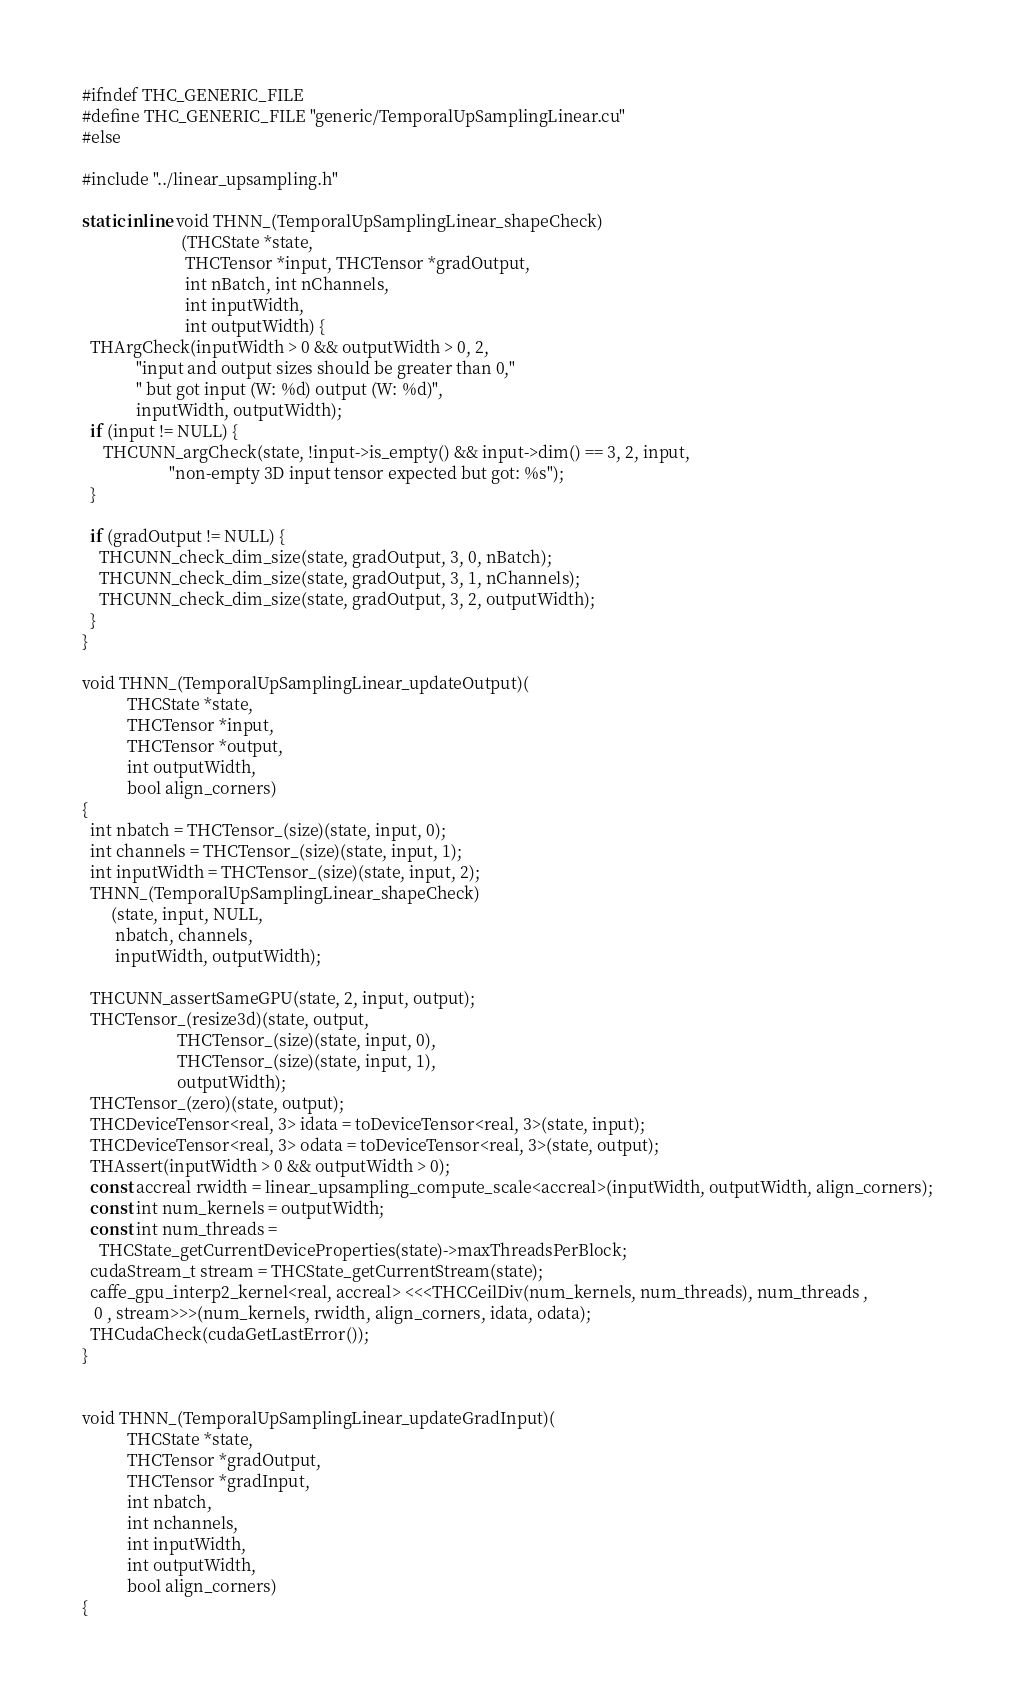Convert code to text. <code><loc_0><loc_0><loc_500><loc_500><_Cuda_>#ifndef THC_GENERIC_FILE
#define THC_GENERIC_FILE "generic/TemporalUpSamplingLinear.cu"
#else

#include "../linear_upsampling.h"

static inline void THNN_(TemporalUpSamplingLinear_shapeCheck)
                        (THCState *state,
                         THCTensor *input, THCTensor *gradOutput,
                         int nBatch, int nChannels,
                         int inputWidth,
                         int outputWidth) {
  THArgCheck(inputWidth > 0 && outputWidth > 0, 2,
             "input and output sizes should be greater than 0,"
             " but got input (W: %d) output (W: %d)",
             inputWidth, outputWidth);
  if (input != NULL) {
     THCUNN_argCheck(state, !input->is_empty() && input->dim() == 3, 2, input,
                     "non-empty 3D input tensor expected but got: %s");
  }

  if (gradOutput != NULL) {
    THCUNN_check_dim_size(state, gradOutput, 3, 0, nBatch);
    THCUNN_check_dim_size(state, gradOutput, 3, 1, nChannels);
    THCUNN_check_dim_size(state, gradOutput, 3, 2, outputWidth);
  }
}

void THNN_(TemporalUpSamplingLinear_updateOutput)(
           THCState *state,
           THCTensor *input,
           THCTensor *output,
           int outputWidth,
           bool align_corners)
{
  int nbatch = THCTensor_(size)(state, input, 0);
  int channels = THCTensor_(size)(state, input, 1);
  int inputWidth = THCTensor_(size)(state, input, 2);
  THNN_(TemporalUpSamplingLinear_shapeCheck)
       (state, input, NULL,
        nbatch, channels,
        inputWidth, outputWidth);

  THCUNN_assertSameGPU(state, 2, input, output);
  THCTensor_(resize3d)(state, output,
                       THCTensor_(size)(state, input, 0),
                       THCTensor_(size)(state, input, 1),
                       outputWidth);
  THCTensor_(zero)(state, output);
  THCDeviceTensor<real, 3> idata = toDeviceTensor<real, 3>(state, input);
  THCDeviceTensor<real, 3> odata = toDeviceTensor<real, 3>(state, output);
  THAssert(inputWidth > 0 && outputWidth > 0);
  const accreal rwidth = linear_upsampling_compute_scale<accreal>(inputWidth, outputWidth, align_corners);
  const int num_kernels = outputWidth;
  const int num_threads =
    THCState_getCurrentDeviceProperties(state)->maxThreadsPerBlock;
  cudaStream_t stream = THCState_getCurrentStream(state);
  caffe_gpu_interp2_kernel<real, accreal> <<<THCCeilDiv(num_kernels, num_threads), num_threads ,
   0 , stream>>>(num_kernels, rwidth, align_corners, idata, odata);
  THCudaCheck(cudaGetLastError());
}


void THNN_(TemporalUpSamplingLinear_updateGradInput)(
           THCState *state,
           THCTensor *gradOutput,
           THCTensor *gradInput,
           int nbatch,
           int nchannels,
           int inputWidth,
           int outputWidth,
           bool align_corners)
{</code> 